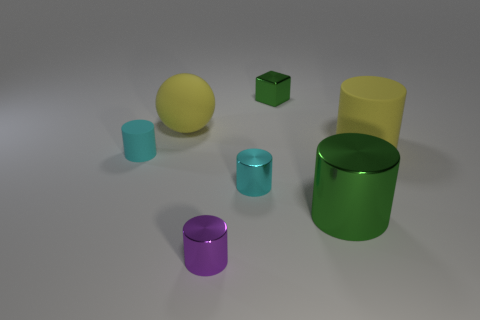What is the shape of the tiny purple shiny object?
Make the answer very short. Cylinder. What size is the yellow rubber object right of the small purple shiny object that is in front of the rubber cylinder right of the large green thing?
Provide a short and direct response. Large. What number of other objects are there of the same shape as the purple object?
Provide a succinct answer. 4. Does the metal thing behind the tiny rubber object have the same shape as the small cyan object that is right of the large yellow sphere?
Offer a terse response. No. How many cylinders are either tiny cyan objects or small purple metal things?
Offer a terse response. 3. What material is the small cyan cylinder that is on the left side of the tiny thing that is in front of the green shiny thing in front of the large yellow sphere?
Provide a succinct answer. Rubber. What number of other things are the same size as the green block?
Your answer should be compact. 3. There is a ball that is the same color as the big rubber cylinder; what is its size?
Your answer should be very brief. Large. Are there more tiny green metal cubes in front of the purple metal object than purple metallic objects?
Offer a terse response. No. Are there any other large rubber balls that have the same color as the ball?
Provide a succinct answer. No. 